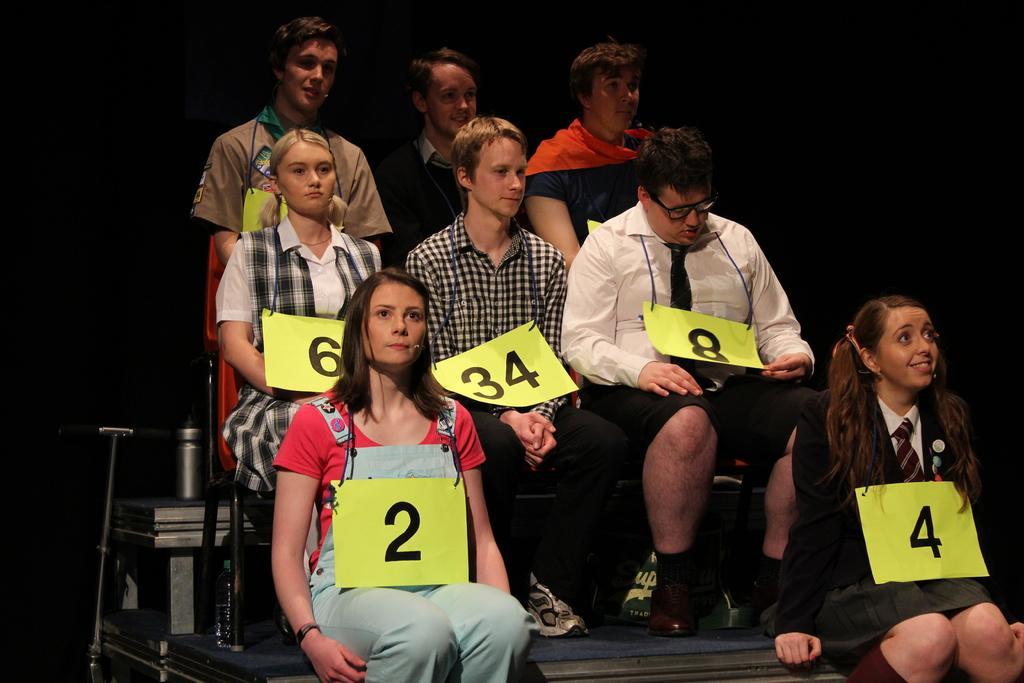Describe this image in one or two sentences. In this picture there are two women who are sitting on the bench. Behind them there are three persons were sitting on the chairs. Behind them there are three men who are standing near to the table. On the table I can see the stick and can. In the background I can see the darkness. 